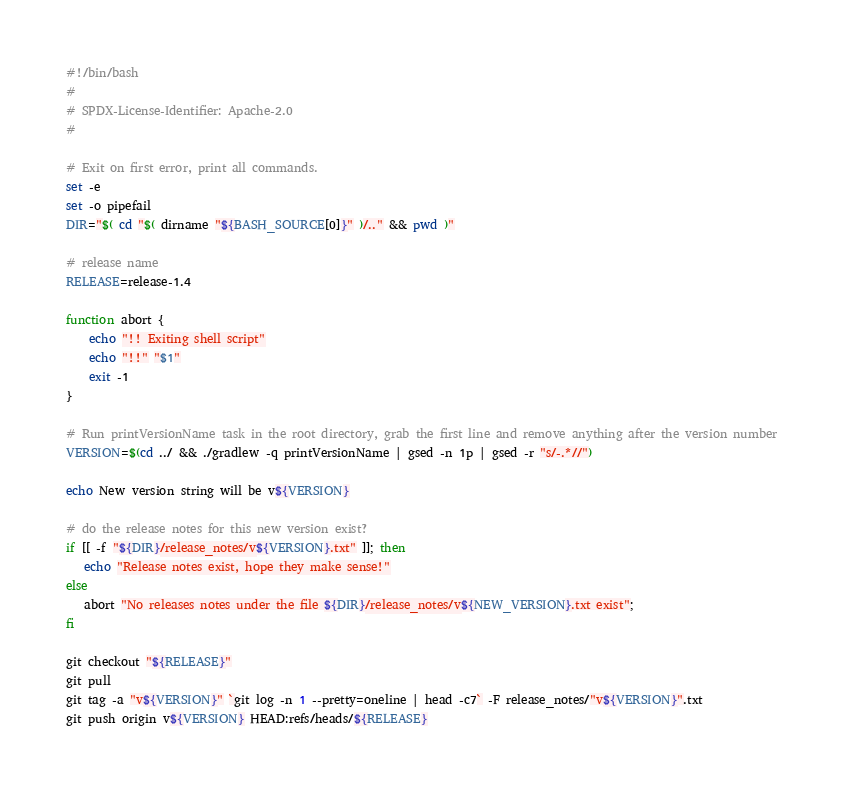<code> <loc_0><loc_0><loc_500><loc_500><_Bash_>#!/bin/bash
#
# SPDX-License-Identifier: Apache-2.0
#

# Exit on first error, print all commands.
set -e
set -o pipefail
DIR="$( cd "$( dirname "${BASH_SOURCE[0]}" )/.." && pwd )"

# release name
RELEASE=release-1.4

function abort {
	echo "!! Exiting shell script"
	echo "!!" "$1"
	exit -1
}

# Run printVersionName task in the root directory, grab the first line and remove anything after the version number
VERSION=$(cd ../ && ./gradlew -q printVersionName | gsed -n 1p | gsed -r "s/-.*//")

echo New version string will be v${VERSION}

# do the release notes for this new version exist?
if [[ -f "${DIR}/release_notes/v${VERSION}.txt" ]]; then
   echo "Release notes exist, hope they make sense!"
else
   abort "No releases notes under the file ${DIR}/release_notes/v${NEW_VERSION}.txt exist";
fi

git checkout "${RELEASE}"
git pull
git tag -a "v${VERSION}" `git log -n 1 --pretty=oneline | head -c7` -F release_notes/"v${VERSION}".txt
git push origin v${VERSION} HEAD:refs/heads/${RELEASE}</code> 